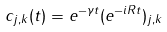Convert formula to latex. <formula><loc_0><loc_0><loc_500><loc_500>c _ { j , k } ( t ) = e ^ { - \gamma t } ( e ^ { - i R t } ) _ { j , k }</formula> 